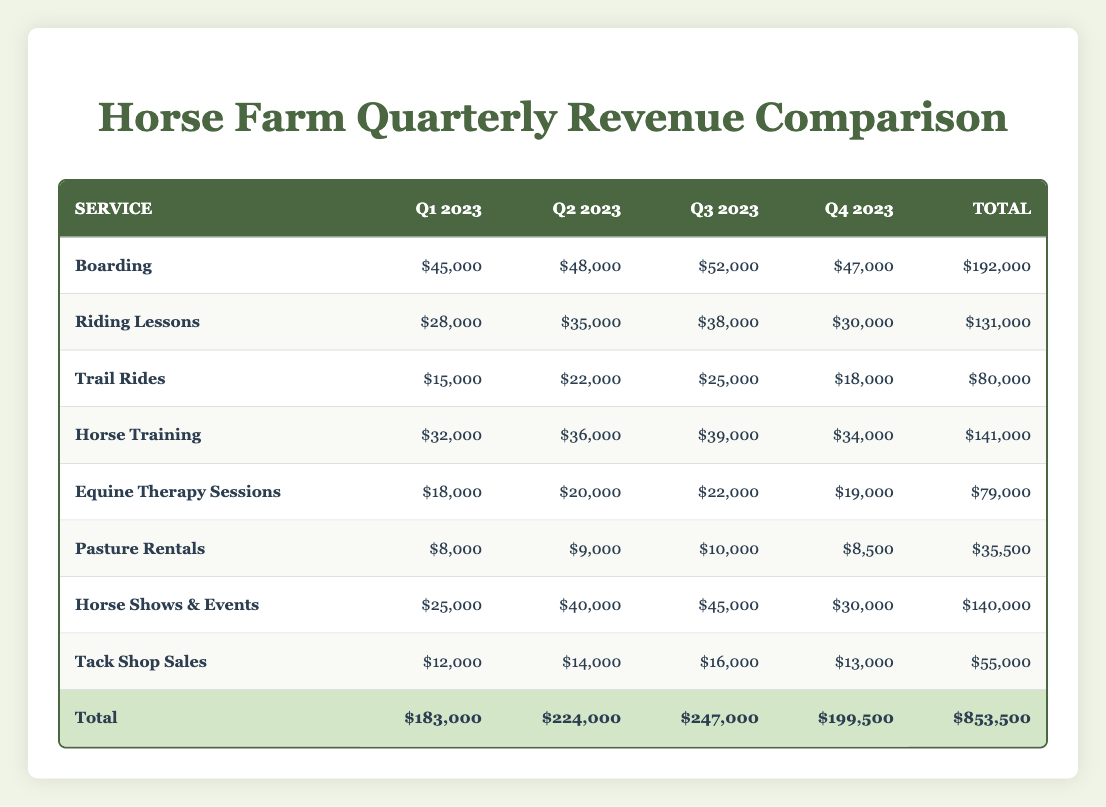What was the total revenue from Boarding in Q3 2023? The table indicates that the revenue from Boarding in Q3 2023 is listed directly, which is $52,000.
Answer: $52,000 Which service had the highest total revenue across all quarters? By summing the revenue for each service across the quarters, Boarding totals $192,000, Riding Lessons $131,000, Trail Rides $80,000, Horse Training $141,000, Equine Therapy Sessions $79,000, Pasture Rentals $35,500, Horse Shows & Events $140,000, and Tack Shop Sales $55,000. Therefore, Boarding has the highest total revenue.
Answer: Boarding What is the percentage increase in revenue from Horse Training between Q1 2023 and Q3 2023? The revenue from Horse Training in Q1 2023 is $32,000, and in Q3 2023 it is $39,000. To calculate percentage increase: ((39,000 - 32,000) / 32,000) * 100 = 21.88%.
Answer: 21.88% Was the revenue from Riding Lessons greater than $35,000 in Q2 2023? In Q2 2023, Riding Lessons revenue is listed at $35,000. Since it is equal, not greater, the answer is false.
Answer: No What is the average revenue for Trail Rides over the four quarters? The revenue for Trail Rides across the quarters is $15,000, $22,000, $25,000, and $18,000. Adding these gives $80,000. Dividing by the 4 quarters gives an average of $80,000 / 4 = $20,000.
Answer: $20,000 How much more did Horse Shows & Events make compared to Pasture Rentals in total? The total revenue for Horse Shows & Events is $140,000 while for Pasture Rentals it totals $35,500. The difference is $140,000 - $35,500 = $104,500.
Answer: $104,500 Was there a decrease in revenue for Tack Shop Sales from Q3 2023 to Q4 2023? The revenue for Tack Shop Sales in Q3 2023 is $16,000 and in Q4 2023 it is $13,000. A decrease is calculated as $16,000 - $13,000 = $3,000, confirming it did decrease.
Answer: Yes Which quarter had the highest overall revenue from all services combined? The total revenue for all services in each quarter is as follows: Q1 is $183,000, Q2 is $224,000, Q3 is $247,000, and Q4 is $199,500. The highest total is in Q3 2023.
Answer: Q3 2023 